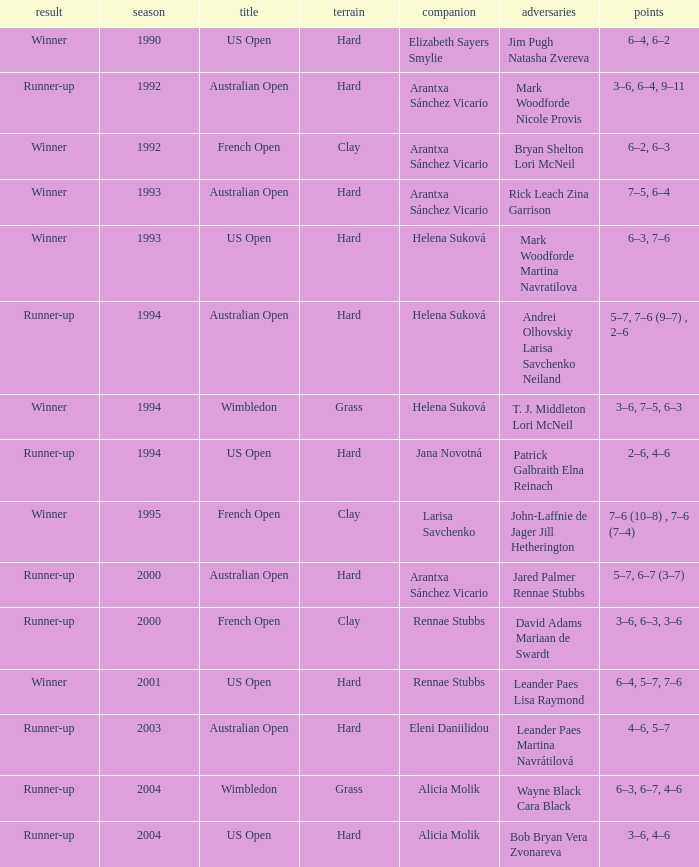Which Score has smaller than 1994, and a Partner of elizabeth sayers smylie? 6–4, 6–2. 